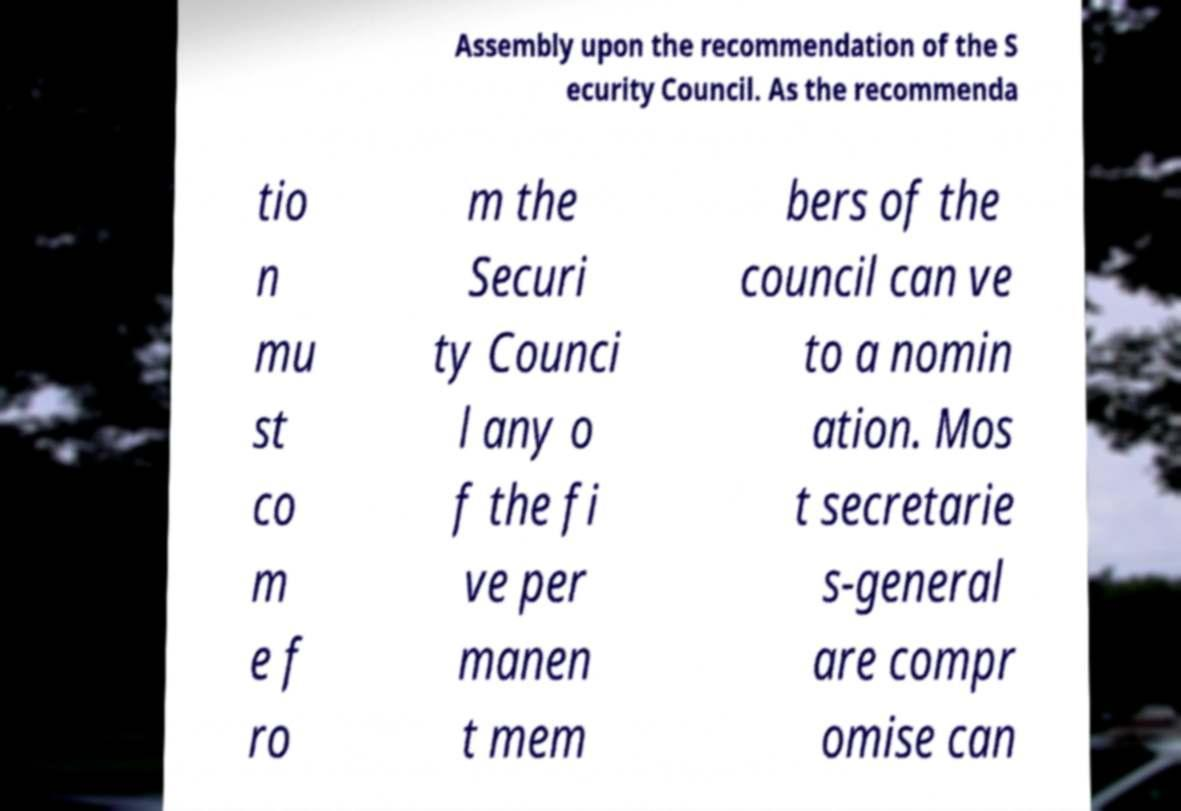I need the written content from this picture converted into text. Can you do that? Assembly upon the recommendation of the S ecurity Council. As the recommenda tio n mu st co m e f ro m the Securi ty Counci l any o f the fi ve per manen t mem bers of the council can ve to a nomin ation. Mos t secretarie s-general are compr omise can 